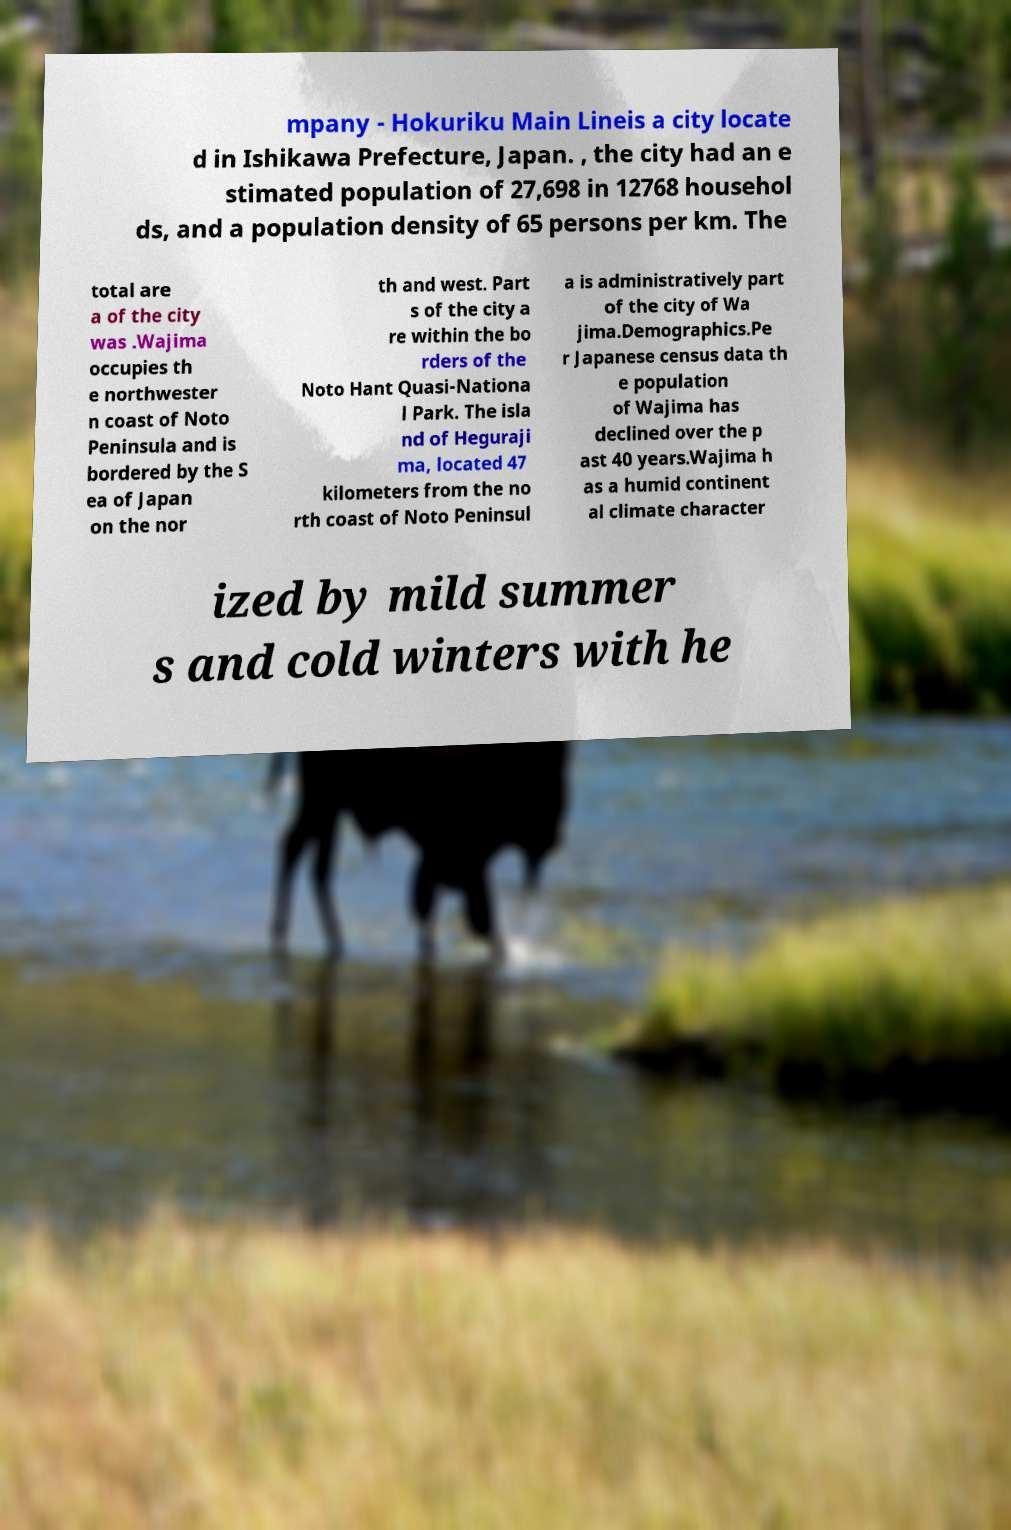Can you accurately transcribe the text from the provided image for me? mpany - Hokuriku Main Lineis a city locate d in Ishikawa Prefecture, Japan. , the city had an e stimated population of 27,698 in 12768 househol ds, and a population density of 65 persons per km. The total are a of the city was .Wajima occupies th e northwester n coast of Noto Peninsula and is bordered by the S ea of Japan on the nor th and west. Part s of the city a re within the bo rders of the Noto Hant Quasi-Nationa l Park. The isla nd of Heguraji ma, located 47 kilometers from the no rth coast of Noto Peninsul a is administratively part of the city of Wa jima.Demographics.Pe r Japanese census data th e population of Wajima has declined over the p ast 40 years.Wajima h as a humid continent al climate character ized by mild summer s and cold winters with he 